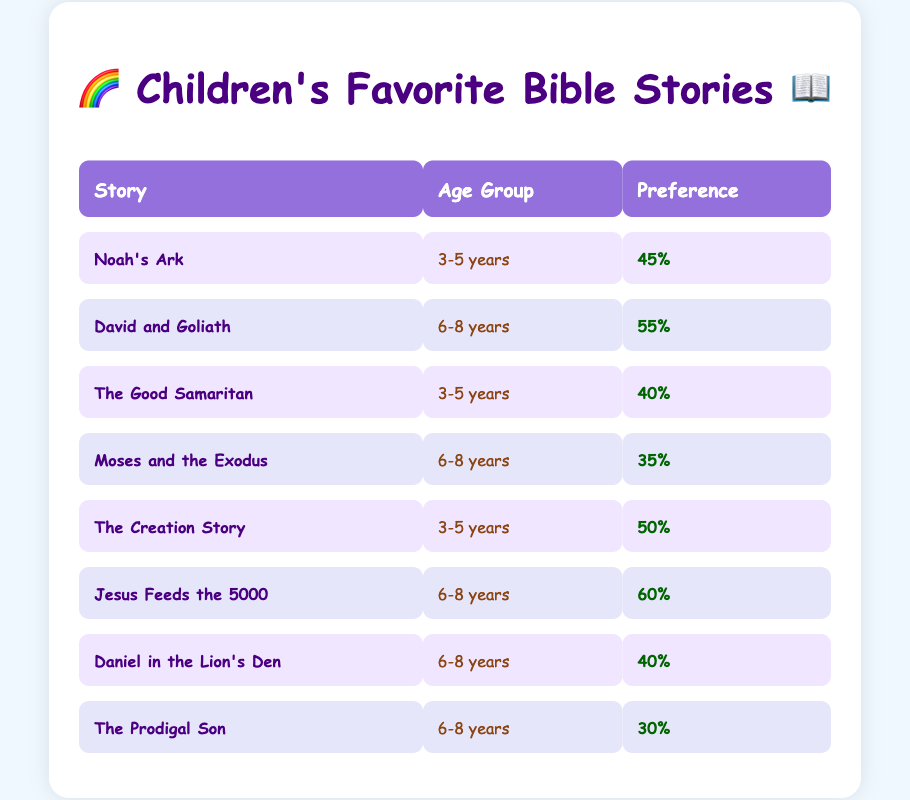What is the preference percentage for "Noah's Ark" among 3-5 year-olds? The table shows that the preference percentage for "Noah's Ark" corresponding to the age group of 3-5 years is listed directly. In the relevant row, the preference is indicated as 45%.
Answer: 45% Which Bible story has the highest preference among 6-8 year-olds? Looking at the rows for the age group 6-8 years, the preference percentages are 55 for "David and Goliath," 60 for "Jesus Feeds the 5000," 40 for "Daniel in the Lion's Den," and 30 for "The Prodigal Son." The highest preference is for "Jesus Feeds the 5000" with 60%.
Answer: Jesus Feeds the 5000 What is the average preference for stories among the age group 3-5 years? The preference percentages for the 3-5 age group are 45 for "Noah's Ark," 40 for "The Good Samaritan," and 50 for "The Creation Story." To find the average, sum these values: 45 + 40 + 50 = 135. There are 3 stories, so the average is 135 divided by 3, which is 45%.
Answer: 45% Is "Moses and the Exodus" preferred more than "The Good Samaritan" for 3-5 year-olds? For the 3-5 age group, "Moses and the Exodus" is not listed; it belongs to the 6-8 age group with a preference of 35%. Meanwhile, "The Good Samaritan," also for 3-5 year-olds, has a preference of 40%. So, comparing the two shows that "The Good Samaritan" is preferred more.
Answer: Yes What is the total preference percentage for all stories in the age group 6-8 years? The preference percentages for the 6-8 age group are 55 for "David and Goliath," 35 for "Moses and the Exodus," 60 for "Jesus Feeds the 5000," 40 for "Daniel in the Lion's Den," and 30 for "The Prodigal Son." Adding these values gives: 55 + 35 + 60 + 40 + 30 = 220.
Answer: 220 